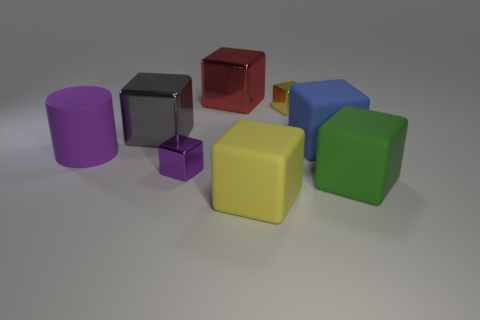Subtract all purple metal cubes. How many cubes are left? 6 Subtract all gray cubes. How many cubes are left? 6 Subtract all red blocks. Subtract all cyan spheres. How many blocks are left? 6 Add 1 tiny metallic objects. How many objects exist? 9 Subtract all cylinders. How many objects are left? 7 Subtract all small purple cylinders. Subtract all yellow metallic cubes. How many objects are left? 7 Add 2 blue cubes. How many blue cubes are left? 3 Add 8 large blue matte things. How many large blue matte things exist? 9 Subtract 0 gray balls. How many objects are left? 8 